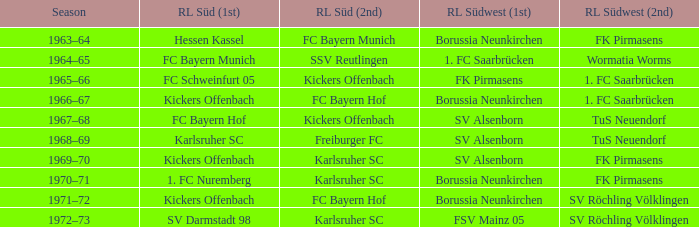During the period when fk pirmasens was the rl südwest (1st), who was the rl süd (1st)? FC Schweinfurt 05. 